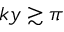Convert formula to latex. <formula><loc_0><loc_0><loc_500><loc_500>k y \gtrsim \pi</formula> 